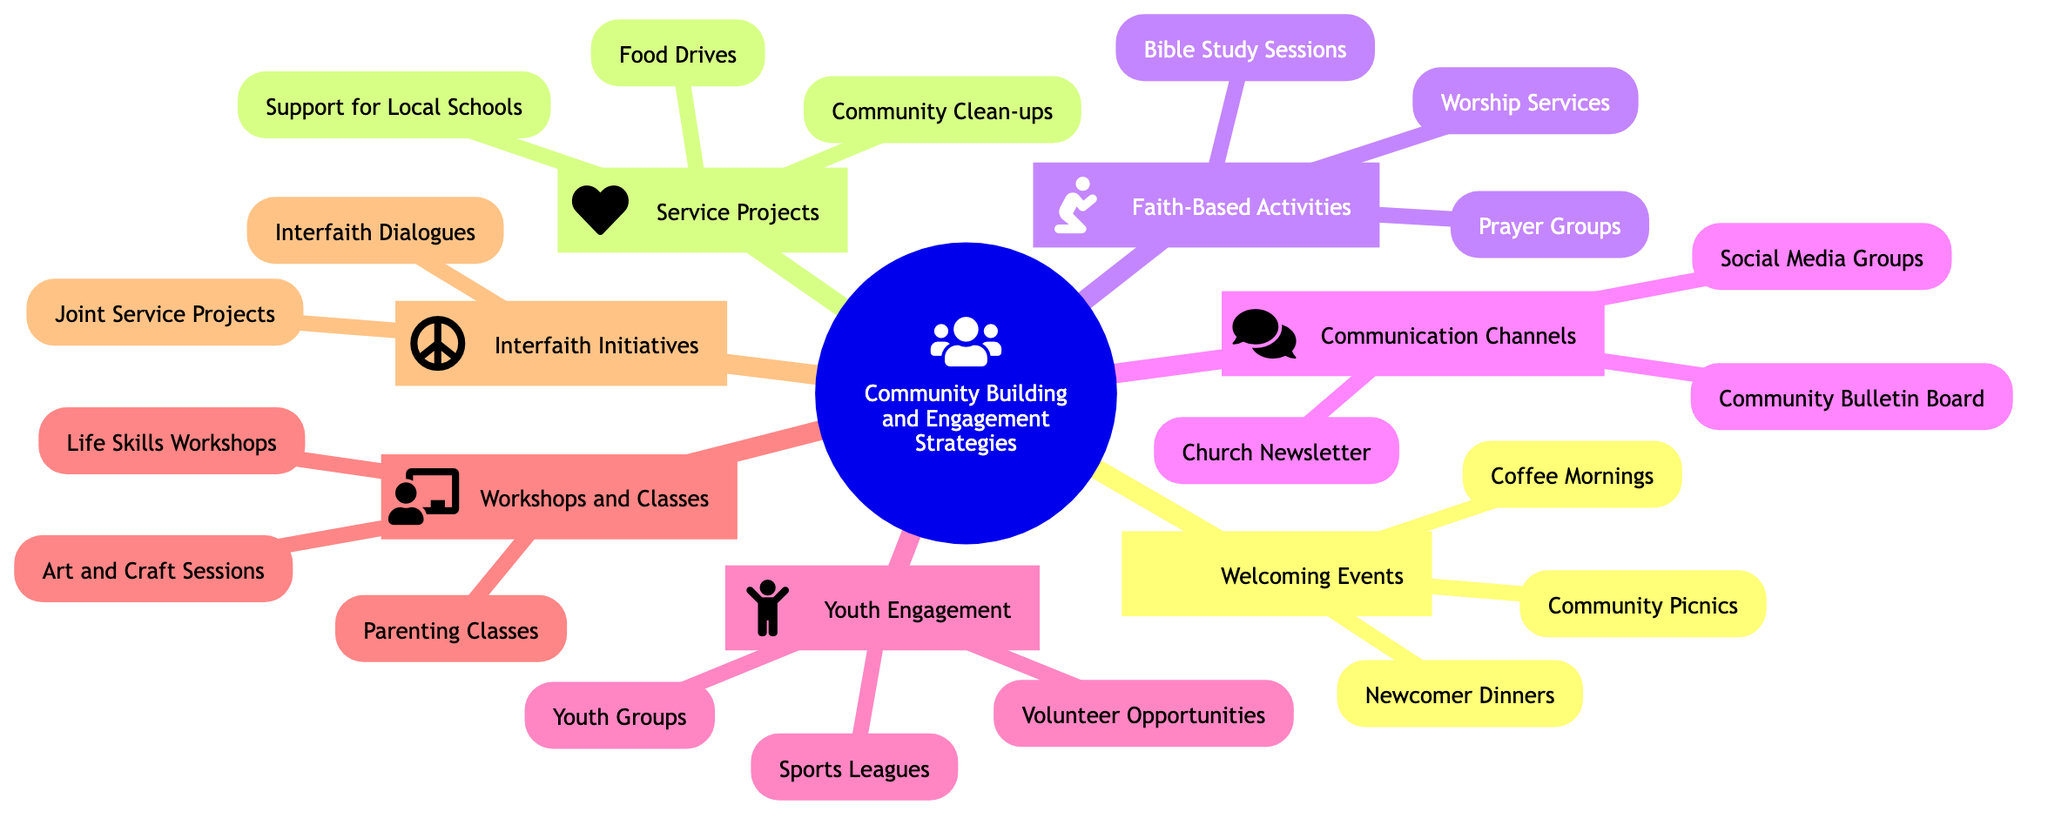What are the three categories of strategies in the diagram? The diagram lists six main categories under "Community Building and Engagement Strategies," which include: Welcoming Events, Service Projects, Faith-Based Activities, Communication Channels, Youth Engagement, Workshops and Classes, and Interfaith Initiatives.
Answer: Welcoming Events, Service Projects, Faith-Based Activities, Communication Channels, Youth Engagement, Workshops and Classes, Interfaith Initiatives How many types of Welcoming Events are there? Under the "Welcoming Events" category, there are three specific types listed: Community Picnics, Coffee Mornings, and Newcomer Dinners. This can be counted directly from the nodes in that section.
Answer: 3 Which category includes "Food Drives"? "Food Drives" is listed under the "Service Projects" category, where it is mentioned as part of the community engagement strategies aimed at helping local shelters.
Answer: Service Projects What type of activity is associated with "Youth Groups"? "Youth Groups" falls under the "Youth Engagement" category, which focuses on activities specifically designed for young members of the community.
Answer: Youth Engagement Are "Art and Craft Sessions" part of Workshops and Classes? Yes, "Art and Craft Sessions" is one of the three specific types of activities listed under the "Workshops and Classes" category, highlighting the community's focus on creativity.
Answer: Yes How many activities are listed under Faith-Based Activities? The "Faith-Based Activities" category contains three activities: Prayer Groups, Bible Study Sessions, and Worship Services. These can be directly counted from those listed under that section.
Answer: 3 Which two types of activities can be found in Communication Channels? Under the "Communication Channels" category, the two types of activities listed are Church Newsletter and Social Media Groups, demonstrating ways to keep community members informed and engaged.
Answer: Church Newsletter, Social Media Groups What are the two types of Interfaith Initiatives mentioned? The "Interfaith Initiatives" category includes two specific activities: Interfaith Dialogues and Joint Service Projects, aimed at fostering collaboration among different faith communities in Tumbler Ridge.
Answer: Interfaith Dialogues, Joint Service Projects 